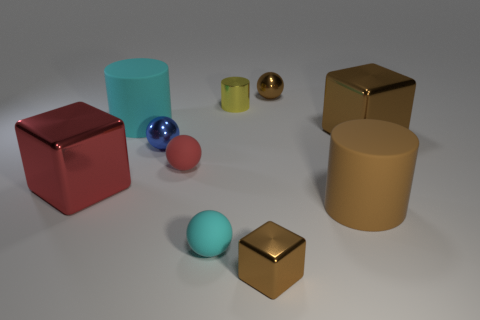How does the lighting in this image affect the appearance of the objects? The lighting in the image is mostly uniform and soft, which minimizes strong shadows and allows the colors and materials of the objects to be clearly seen. It provides a gentle contrast that helps to distinguish the matte and metallic surfaces. 